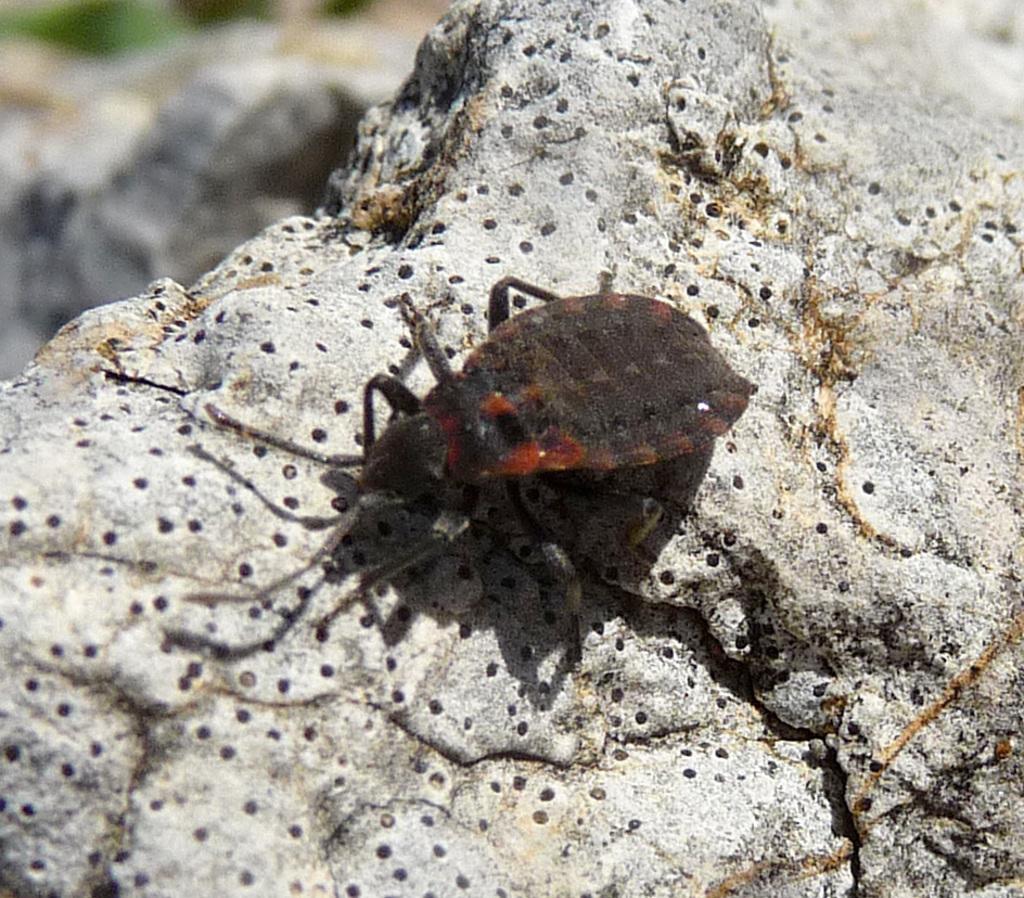Can you describe this image briefly? In the center of the image we can see a bug on the rock. 